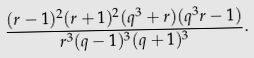<formula> <loc_0><loc_0><loc_500><loc_500>\frac { ( r - 1 ) ^ { 2 } ( r + 1 ) ^ { 2 } ( q ^ { 3 } + r ) ( q ^ { 3 } r - 1 ) } { r ^ { 3 } ( q - 1 ) ^ { 3 } ( q + 1 ) ^ { 3 } } .</formula> 